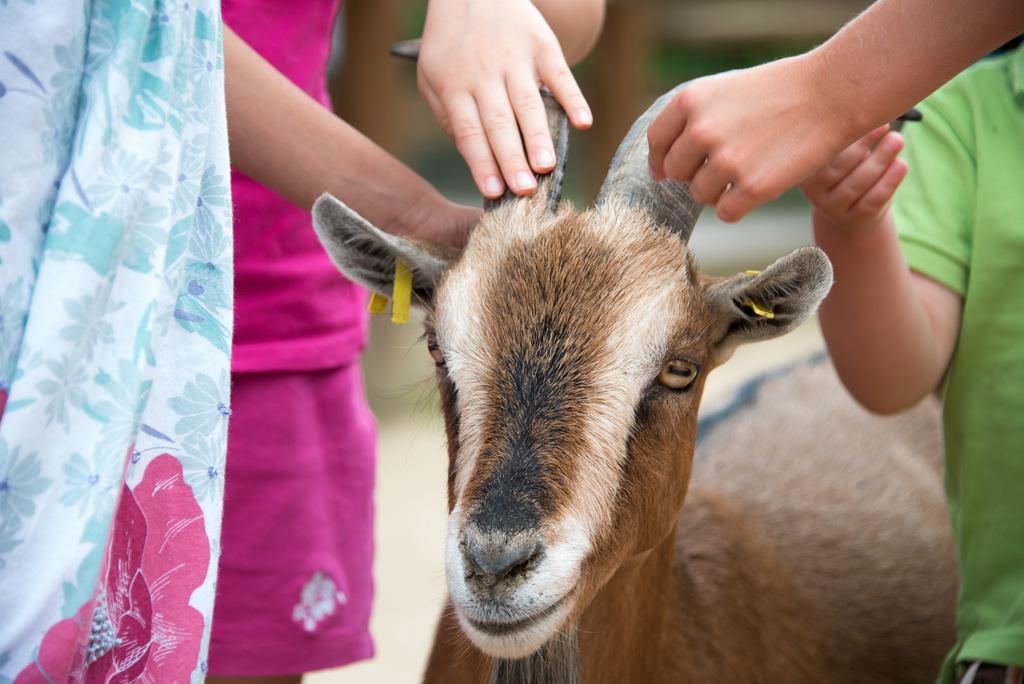What animal is present in the picture? There is a goat in the picture. What can be seen on the goat? People's hands are on the goat. What type of oatmeal is being served in the picture? There is no oatmeal present in the picture; it features a goat with people's hands on it. How does the stomach of the goat look in the picture? The picture does not show the goat's stomach, so it cannot be described. 